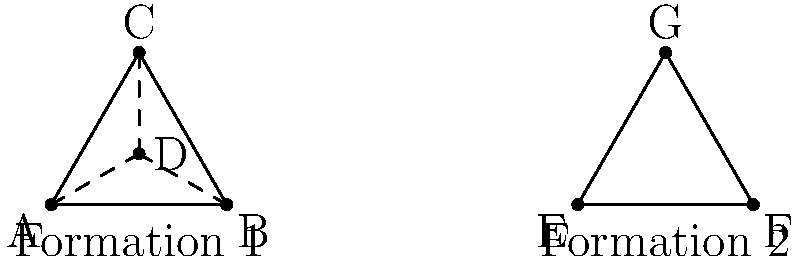Consider two rugby play formations as shown in the diagram. Formation 1 is a triangle with a central player, while Formation 2 is a simple triangle. Define a group homomorphism $\phi$ from the symmetry group of Formation 1 to the symmetry group of Formation 2. How many elements are in the kernel of $\phi$? Let's approach this step-by-step:

1) First, we need to identify the symmetry groups of both formations:
   - Formation 1 (triangle with central player) has 6 symmetries (rotations by 0°, 120°, 240°, and reflections over three axes).
   - Formation 2 (simple triangle) has 6 symmetries (rotations by 0°, 120°, 240°, and reflections over three axes).

2) We can define a homomorphism $\phi$ that maps the symmetries of Formation 1 to Formation 2 by ignoring the central player D.

3) This homomorphism $\phi$ is surjective (onto) because every symmetry of Formation 2 is the image of at least one symmetry of Formation 1.

4) The kernel of $\phi$ consists of all symmetries of Formation 1 that map to the identity in Formation 2.

5) The only symmetry of Formation 1 that maps to the identity in Formation 2 is the identity itself. Any non-identity symmetry of Formation 1 will result in a non-identity symmetry of Formation 2.

6) Therefore, the kernel of $\phi$ contains only the identity element.

7) By the definition of a group, the kernel always contains at least the identity element, so in this case, the kernel has exactly one element.
Answer: 1 